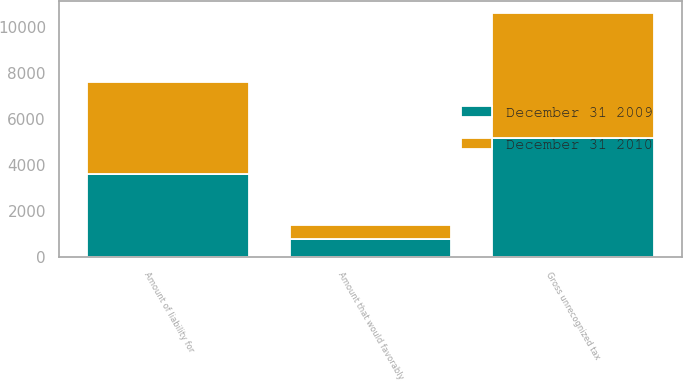<chart> <loc_0><loc_0><loc_500><loc_500><stacked_bar_chart><ecel><fcel>Gross unrecognized tax<fcel>Amount that would favorably<fcel>Amount of liability for<nl><fcel>December 31 2009<fcel>5169<fcel>785<fcel>3605<nl><fcel>December 31 2010<fcel>5410<fcel>618<fcel>4007<nl></chart> 